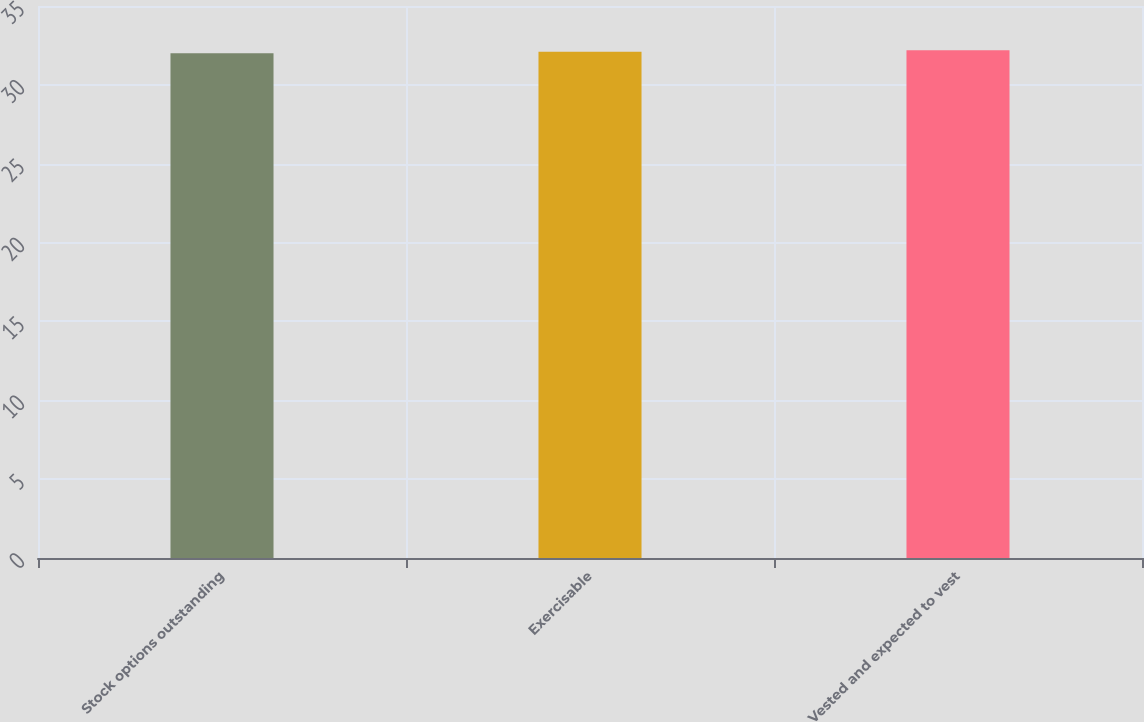Convert chart to OTSL. <chart><loc_0><loc_0><loc_500><loc_500><bar_chart><fcel>Stock options outstanding<fcel>Exercisable<fcel>Vested and expected to vest<nl><fcel>32<fcel>32.1<fcel>32.2<nl></chart> 